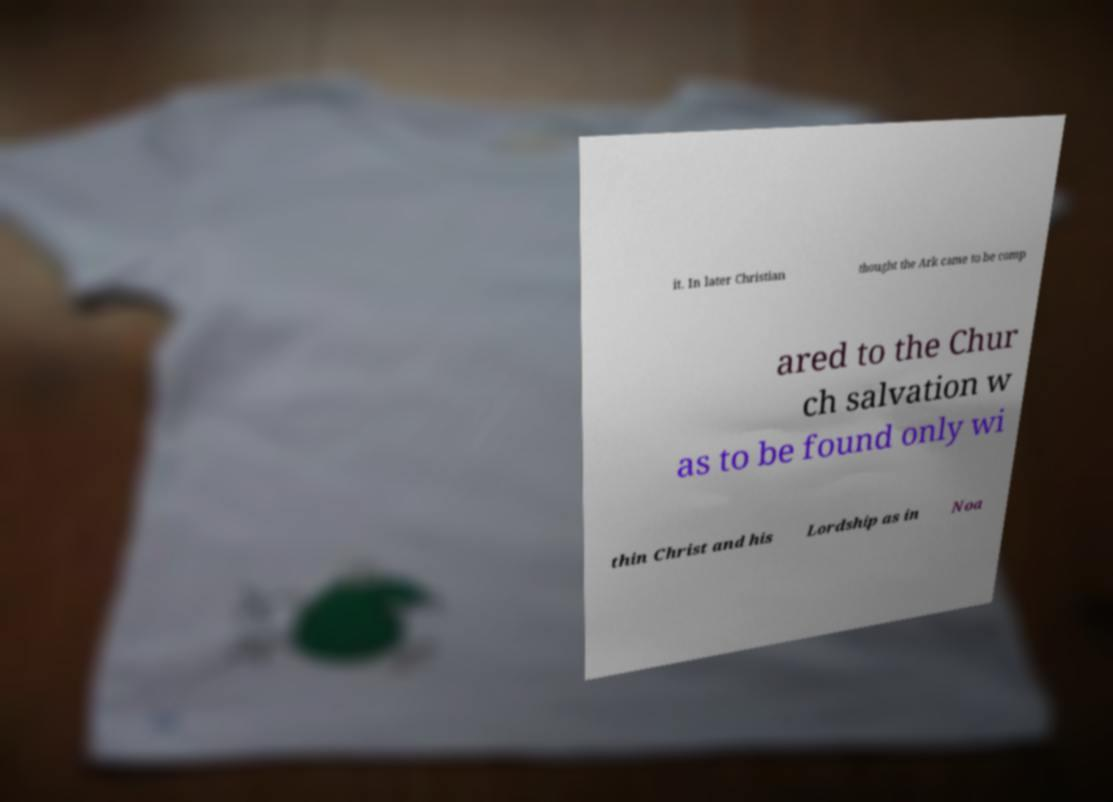I need the written content from this picture converted into text. Can you do that? it. In later Christian thought the Ark came to be comp ared to the Chur ch salvation w as to be found only wi thin Christ and his Lordship as in Noa 